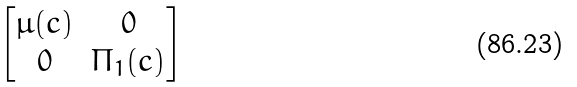Convert formula to latex. <formula><loc_0><loc_0><loc_500><loc_500>\begin{bmatrix} \mu ( c ) & 0 \\ 0 & \Pi _ { 1 } ( c ) \end{bmatrix}</formula> 